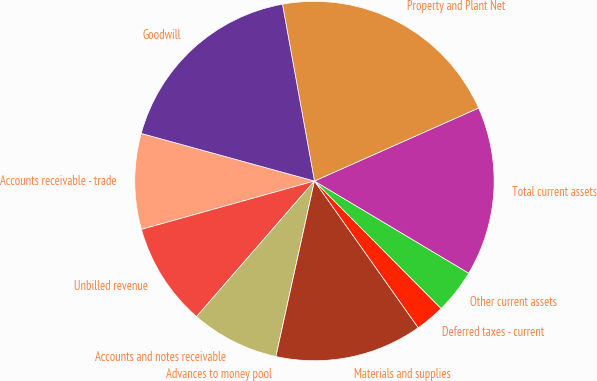Convert chart to OTSL. <chart><loc_0><loc_0><loc_500><loc_500><pie_chart><fcel>Accounts receivable - trade<fcel>Unbilled revenue<fcel>Accounts and notes receivable<fcel>Advances to money pool<fcel>Materials and supplies<fcel>Deferred taxes - current<fcel>Other current assets<fcel>Total current assets<fcel>Property and Plant Net<fcel>Goodwill<nl><fcel>8.61%<fcel>9.27%<fcel>7.95%<fcel>0.0%<fcel>13.24%<fcel>2.65%<fcel>3.98%<fcel>15.23%<fcel>21.19%<fcel>17.88%<nl></chart> 